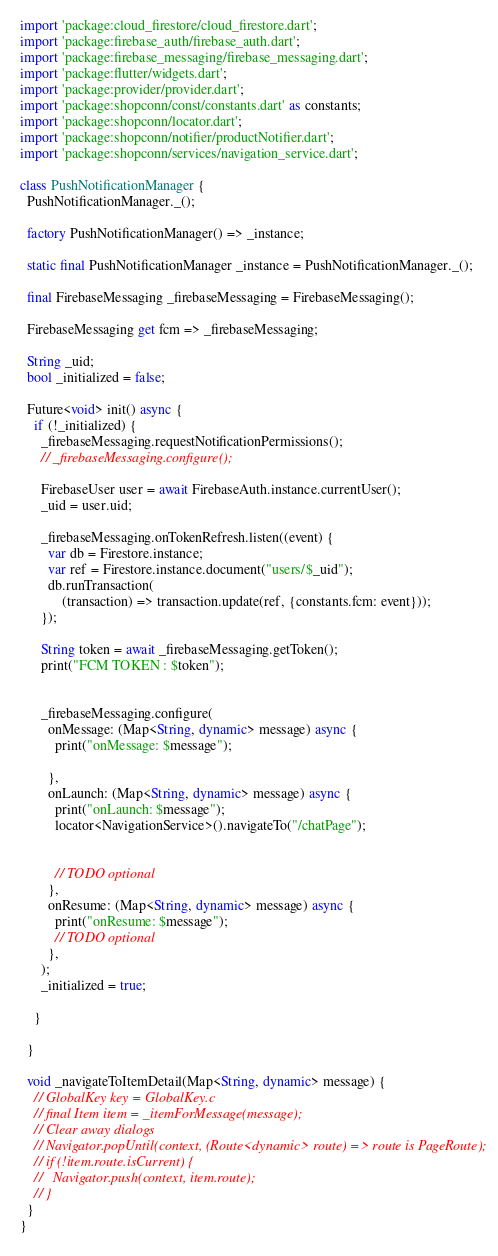<code> <loc_0><loc_0><loc_500><loc_500><_Dart_>
import 'package:cloud_firestore/cloud_firestore.dart';
import 'package:firebase_auth/firebase_auth.dart';
import 'package:firebase_messaging/firebase_messaging.dart';
import 'package:flutter/widgets.dart';
import 'package:provider/provider.dart';
import 'package:shopconn/const/constants.dart' as constants;
import 'package:shopconn/locator.dart';
import 'package:shopconn/notifier/productNotifier.dart';
import 'package:shopconn/services/navigation_service.dart';

class PushNotificationManager {
  PushNotificationManager._();

  factory PushNotificationManager() => _instance;

  static final PushNotificationManager _instance = PushNotificationManager._();

  final FirebaseMessaging _firebaseMessaging = FirebaseMessaging();

  FirebaseMessaging get fcm => _firebaseMessaging;

  String _uid;
  bool _initialized = false;

  Future<void> init() async {
    if (!_initialized) {
      _firebaseMessaging.requestNotificationPermissions();
      // _firebaseMessaging.configure();

      FirebaseUser user = await FirebaseAuth.instance.currentUser();
      _uid = user.uid;

      _firebaseMessaging.onTokenRefresh.listen((event) {
        var db = Firestore.instance;
        var ref = Firestore.instance.document("users/$_uid");
        db.runTransaction(
            (transaction) => transaction.update(ref, {constants.fcm: event}));
      });

      String token = await _firebaseMessaging.getToken();
      print("FCM TOKEN : $token");


      _firebaseMessaging.configure(
        onMessage: (Map<String, dynamic> message) async {
          print("onMessage: $message");

        },
        onLaunch: (Map<String, dynamic> message) async {
          print("onLaunch: $message");
          locator<NavigationService>().navigateTo("/chatPage");
          

          // TODO optional
        },
        onResume: (Map<String, dynamic> message) async {
          print("onResume: $message");
          // TODO optional
        },
      );
      _initialized = true;

    }

  }

  void _navigateToItemDetail(Map<String, dynamic> message) {
    // GlobalKey key = GlobalKey.c
    // final Item item = _itemForMessage(message);
    // Clear away dialogs
    // Navigator.popUntil(context, (Route<dynamic> route) => route is PageRoute);
    // if (!item.route.isCurrent) {
    //   Navigator.push(context, item.route);
    // }
  }
}
</code> 